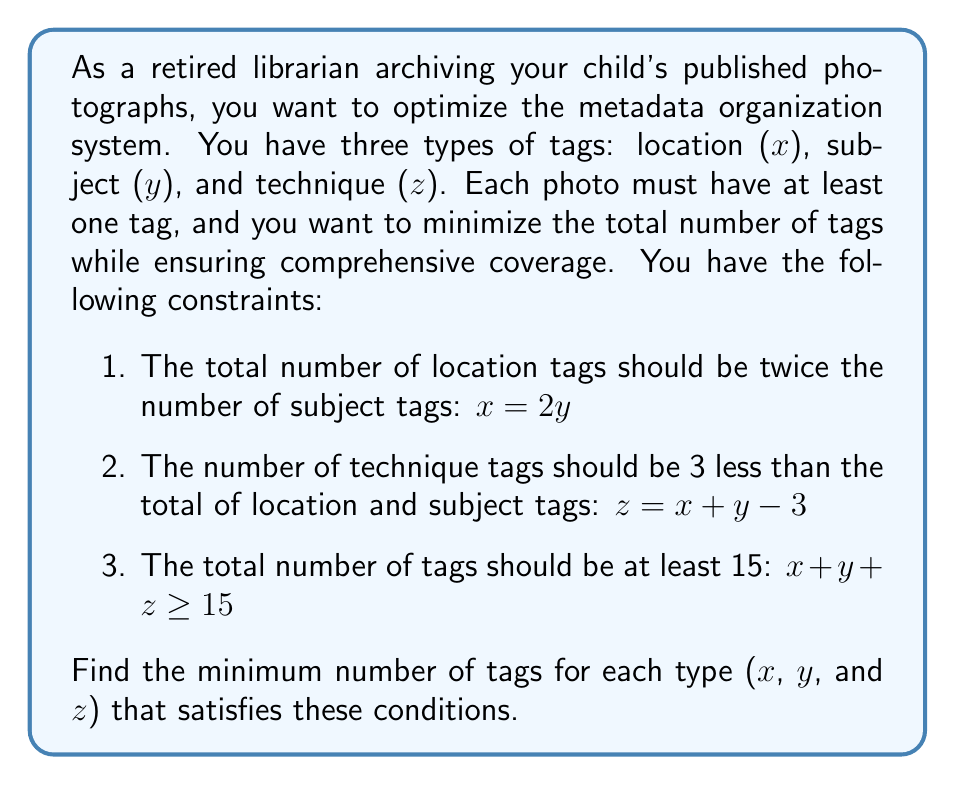Help me with this question. Let's solve this system of linear equations step by step:

1. From the first equation: $x = 2y$

2. Substitute this into the second equation:
   $z = x + y - 3$
   $z = 2y + y - 3$
   $z = 3y - 3$

3. Now, let's use the third inequality:
   $x + y + z \geq 15$
   $2y + y + (3y - 3) \geq 15$
   $6y - 3 \geq 15$
   $6y \geq 18$
   $y \geq 3$

4. Since we want to minimize the total number of tags, we'll use the smallest possible value for y, which is 3.

5. Now we can calculate x and z:
   $x = 2y = 2(3) = 6$
   $z = 3y - 3 = 3(3) - 3 = 6$

6. Let's verify that this solution satisfies all conditions:
   - $x = 2y$ : $6 = 2(3)$ ✓
   - $z = x + y - 3$ : $6 = 6 + 3 - 3$ ✓
   - $x + y + z \geq 15$ : $6 + 3 + 6 = 15$ ✓

Therefore, the minimum number of tags that satisfies all conditions is:
x (location) = 6, y (subject) = 3, and z (technique) = 6.
Answer: $(6, 3, 6)$ 